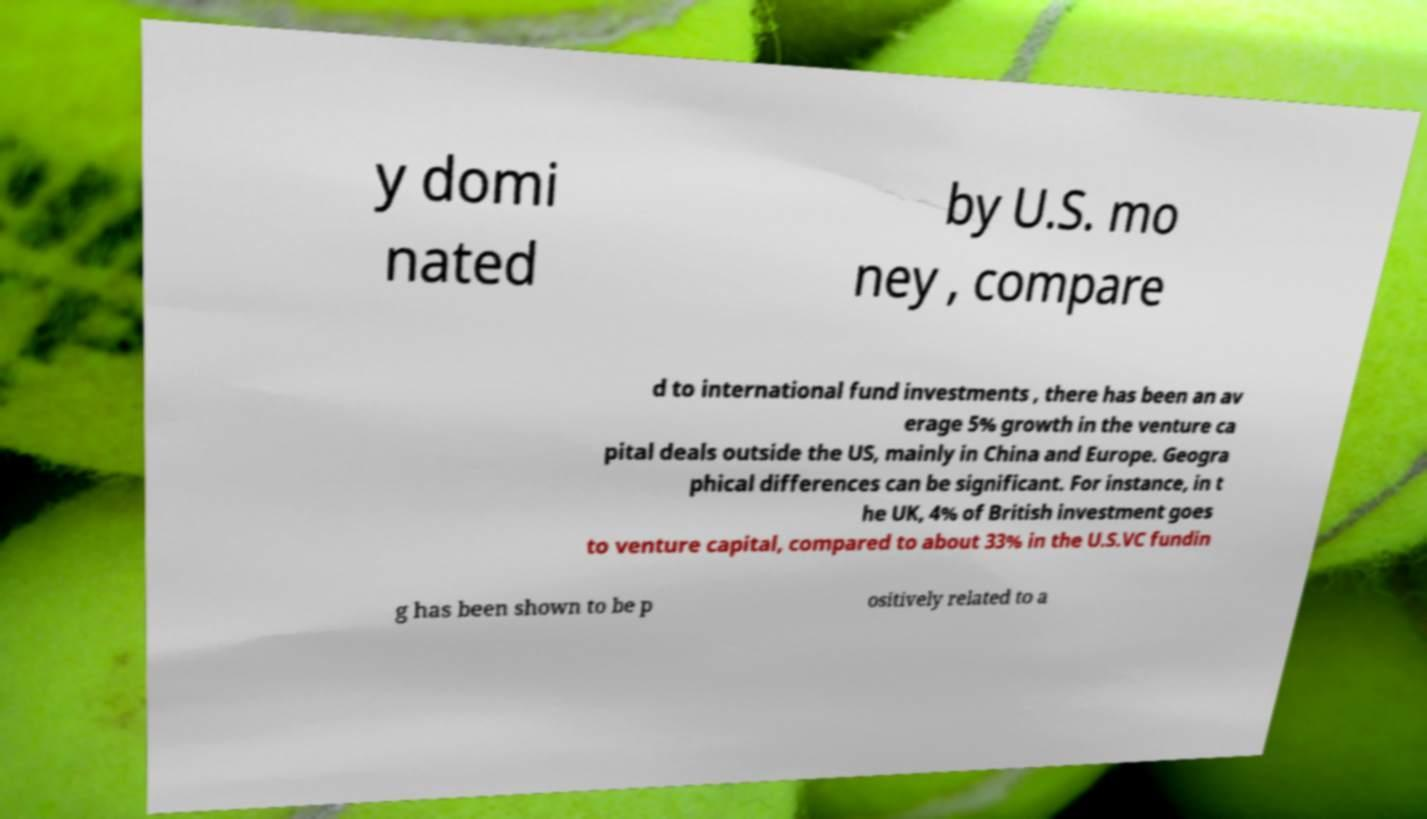I need the written content from this picture converted into text. Can you do that? y domi nated by U.S. mo ney , compare d to international fund investments , there has been an av erage 5% growth in the venture ca pital deals outside the US, mainly in China and Europe. Geogra phical differences can be significant. For instance, in t he UK, 4% of British investment goes to venture capital, compared to about 33% in the U.S.VC fundin g has been shown to be p ositively related to a 